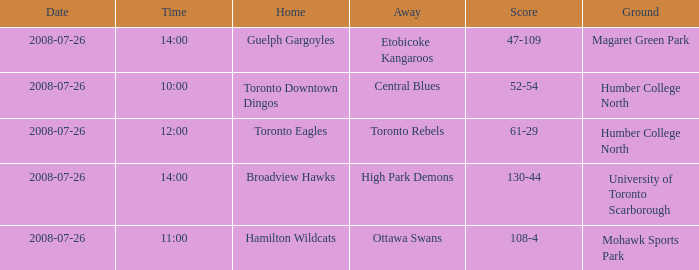With the Ground of Humber College North at 12:00, what was the Away? Toronto Rebels. 